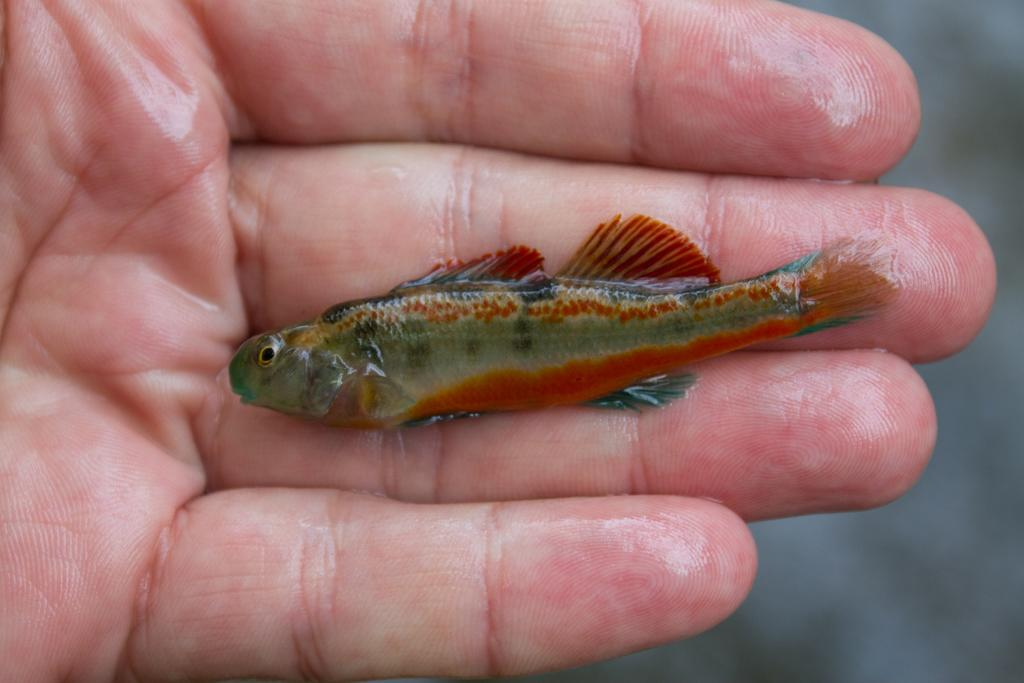What can be seen on the person's hand in the image? There is a fish on the hand. Can you describe the fish in the image? The fish is colorful. What type of sugar is being used to decorate the marble in the image? There is no sugar or marble present in the image; it features a person's hand with a colorful fish on it. 